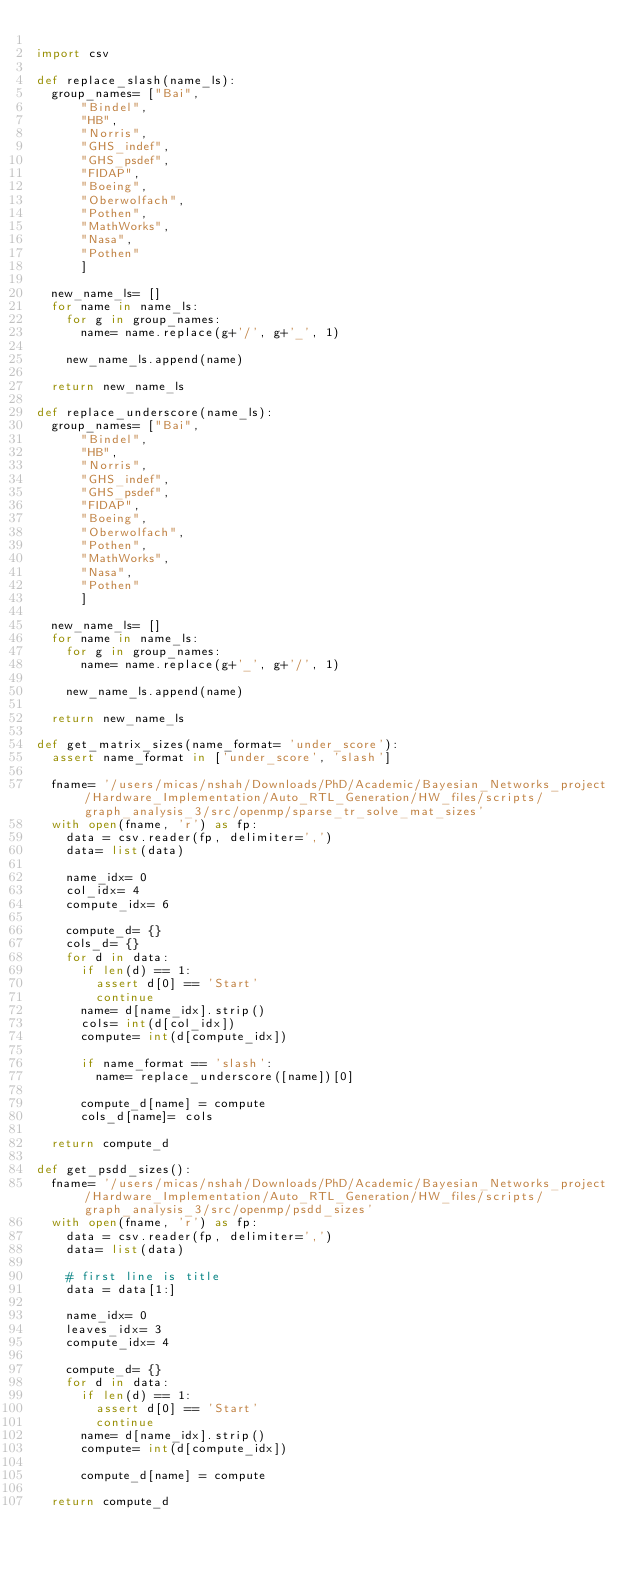Convert code to text. <code><loc_0><loc_0><loc_500><loc_500><_Python_>
import csv

def replace_slash(name_ls):
  group_names= ["Bai", 
      "Bindel",
      "HB",
      "Norris",
      "GHS_indef",
      "GHS_psdef",
      "FIDAP",
      "Boeing",
      "Oberwolfach",
      "Pothen",
      "MathWorks",
      "Nasa",
      "Pothen"
      ]
  
  new_name_ls= []
  for name in name_ls:
    for g in group_names:
      name= name.replace(g+'/', g+'_', 1)
    
    new_name_ls.append(name)

  return new_name_ls

def replace_underscore(name_ls):
  group_names= ["Bai", 
      "Bindel",
      "HB",
      "Norris",
      "GHS_indef",
      "GHS_psdef",
      "FIDAP",
      "Boeing",
      "Oberwolfach",
      "Pothen",
      "MathWorks",
      "Nasa",
      "Pothen"
      ]
  
  new_name_ls= []
  for name in name_ls:
    for g in group_names:
      name= name.replace(g+'_', g+'/', 1)
    
    new_name_ls.append(name)

  return new_name_ls

def get_matrix_sizes(name_format= 'under_score'):
  assert name_format in ['under_score', 'slash']

  fname= '/users/micas/nshah/Downloads/PhD/Academic/Bayesian_Networks_project/Hardware_Implementation/Auto_RTL_Generation/HW_files/scripts/graph_analysis_3/src/openmp/sparse_tr_solve_mat_sizes'
  with open(fname, 'r') as fp:
    data = csv.reader(fp, delimiter=',')
    data= list(data)

    name_idx= 0
    col_idx= 4
    compute_idx= 6

    compute_d= {}
    cols_d= {}
    for d in data:
      if len(d) == 1:
        assert d[0] == 'Start'
        continue
      name= d[name_idx].strip()
      cols= int(d[col_idx])
      compute= int(d[compute_idx])

      if name_format == 'slash':
        name= replace_underscore([name])[0]
      
      compute_d[name] = compute
      cols_d[name]= cols
  
  return compute_d

def get_psdd_sizes():
  fname= '/users/micas/nshah/Downloads/PhD/Academic/Bayesian_Networks_project/Hardware_Implementation/Auto_RTL_Generation/HW_files/scripts/graph_analysis_3/src/openmp/psdd_sizes'
  with open(fname, 'r') as fp:
    data = csv.reader(fp, delimiter=',')
    data= list(data)
    
    # first line is title
    data = data[1:]

    name_idx= 0
    leaves_idx= 3
    compute_idx= 4

    compute_d= {}
    for d in data:
      if len(d) == 1:
        assert d[0] == 'Start'
        continue
      name= d[name_idx].strip()
      compute= int(d[compute_idx])

      compute_d[name] = compute
  
  return compute_d

</code> 